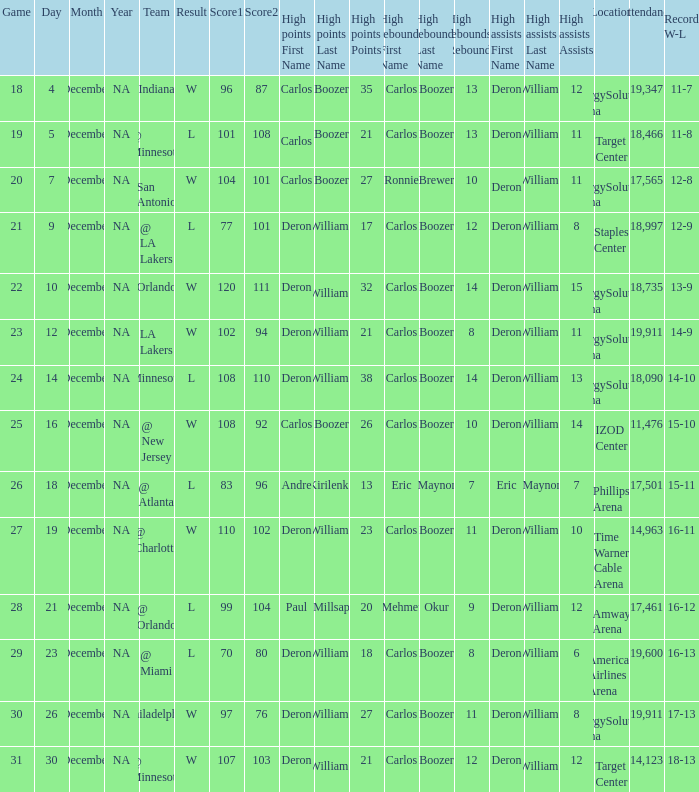How many different high rebound results are there for the game number 26? 1.0. 